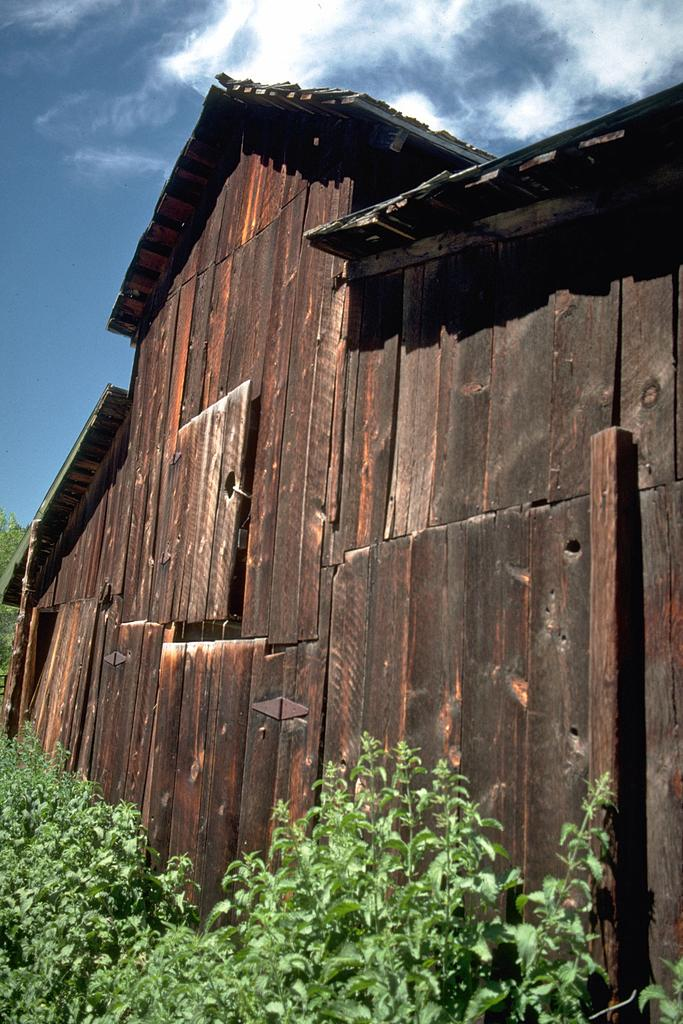What type of house is in the picture? There is a wooden house in the picture. What else can be seen in the picture besides the house? There are plants and the sky visible in the picture. What is the condition of the sky in the picture? Clouds are present in the sky. How much debt does the cabbage owe in the image? There is no cabbage or mention of debt in the image. What type of corn is growing in the garden in the image? There is no garden or corn present in the image. 